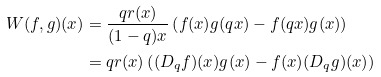<formula> <loc_0><loc_0><loc_500><loc_500>W ( f , g ) ( x ) & = \frac { q r ( x ) } { ( 1 - q ) x } \left ( f ( x ) g ( q x ) - f ( q x ) g ( x ) \right ) \\ & = q r ( x ) \left ( ( D _ { q } f ) ( x ) g ( x ) - f ( x ) ( D _ { q } g ) ( x ) \right )</formula> 